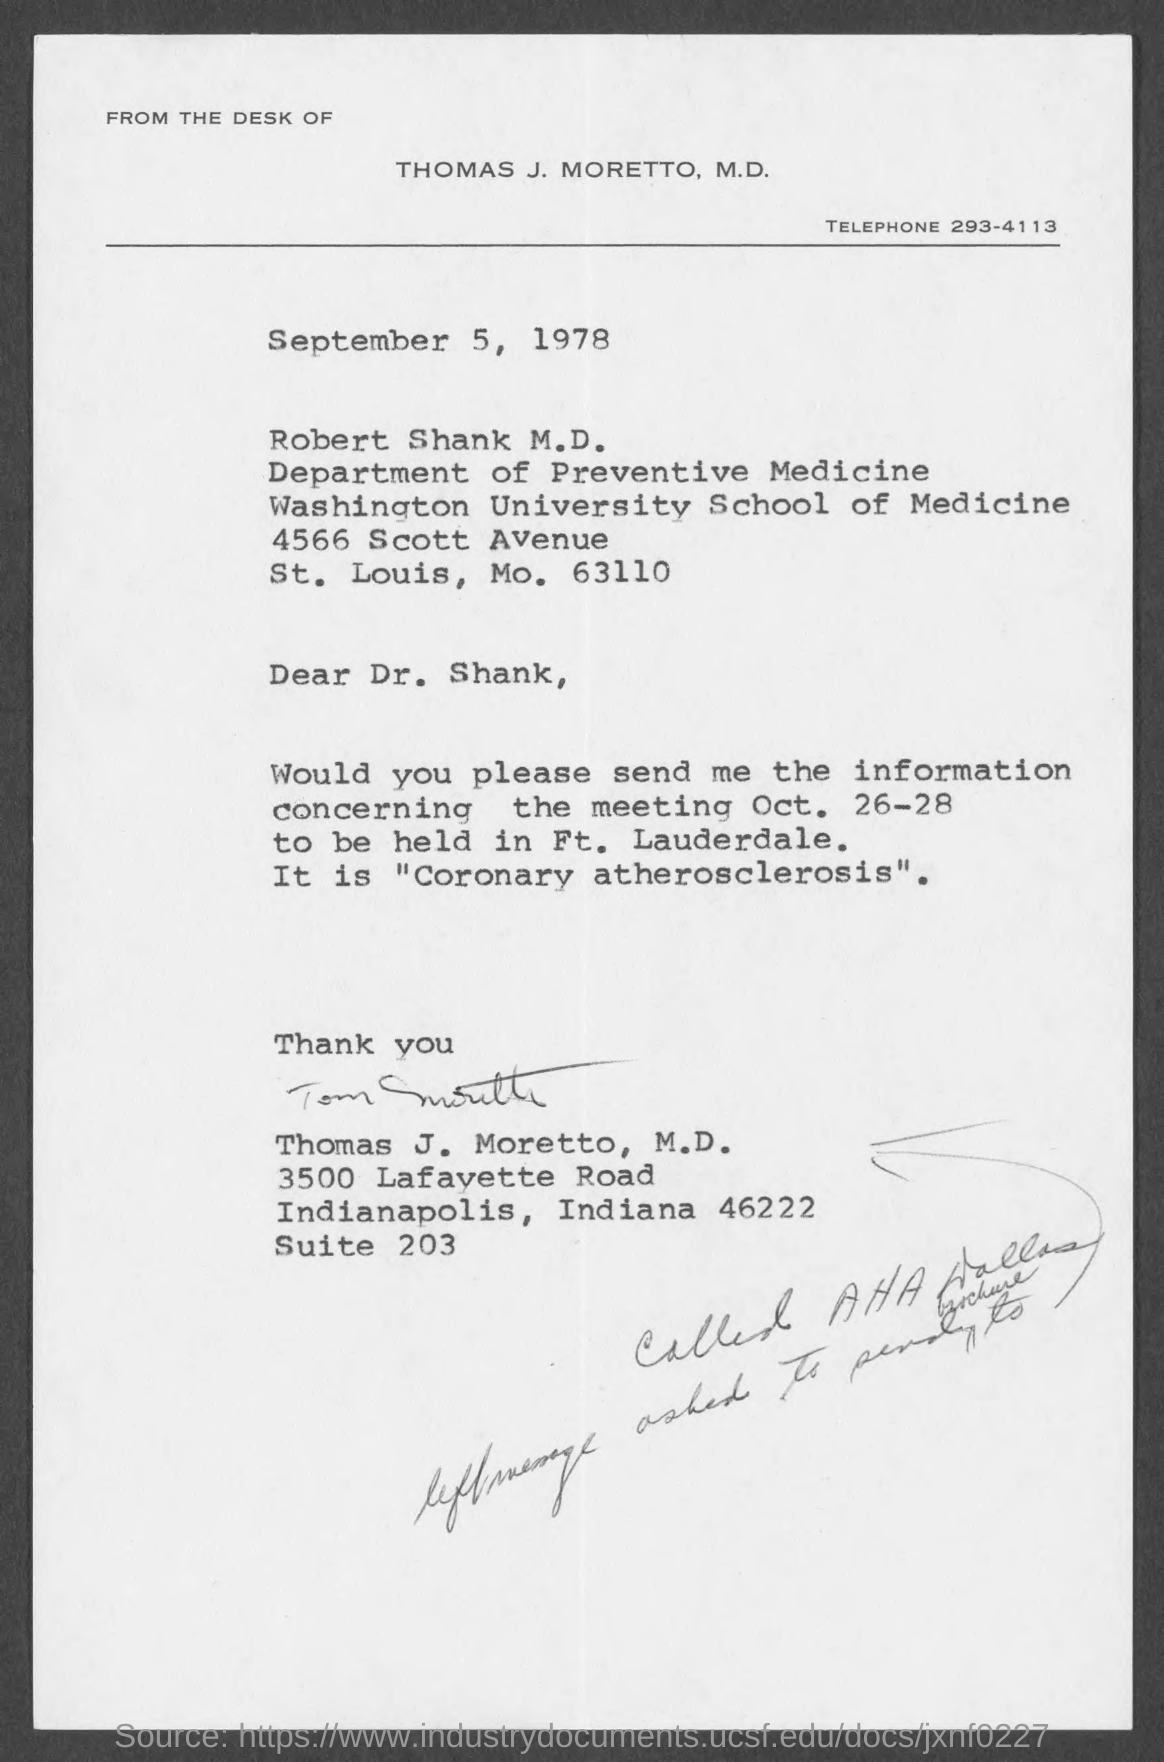What is the Telephone No of Thomas J. Moretto, M.D.?
Keep it short and to the point. 293-4113. What is the issued date of this letter?
Your answer should be compact. September 5, 1978. In which department, Robert Shank M.D. works?
Your answer should be compact. Department of Preventive Medicine. Who has signed this letter?
Your response must be concise. Thomas J. Moretto. 